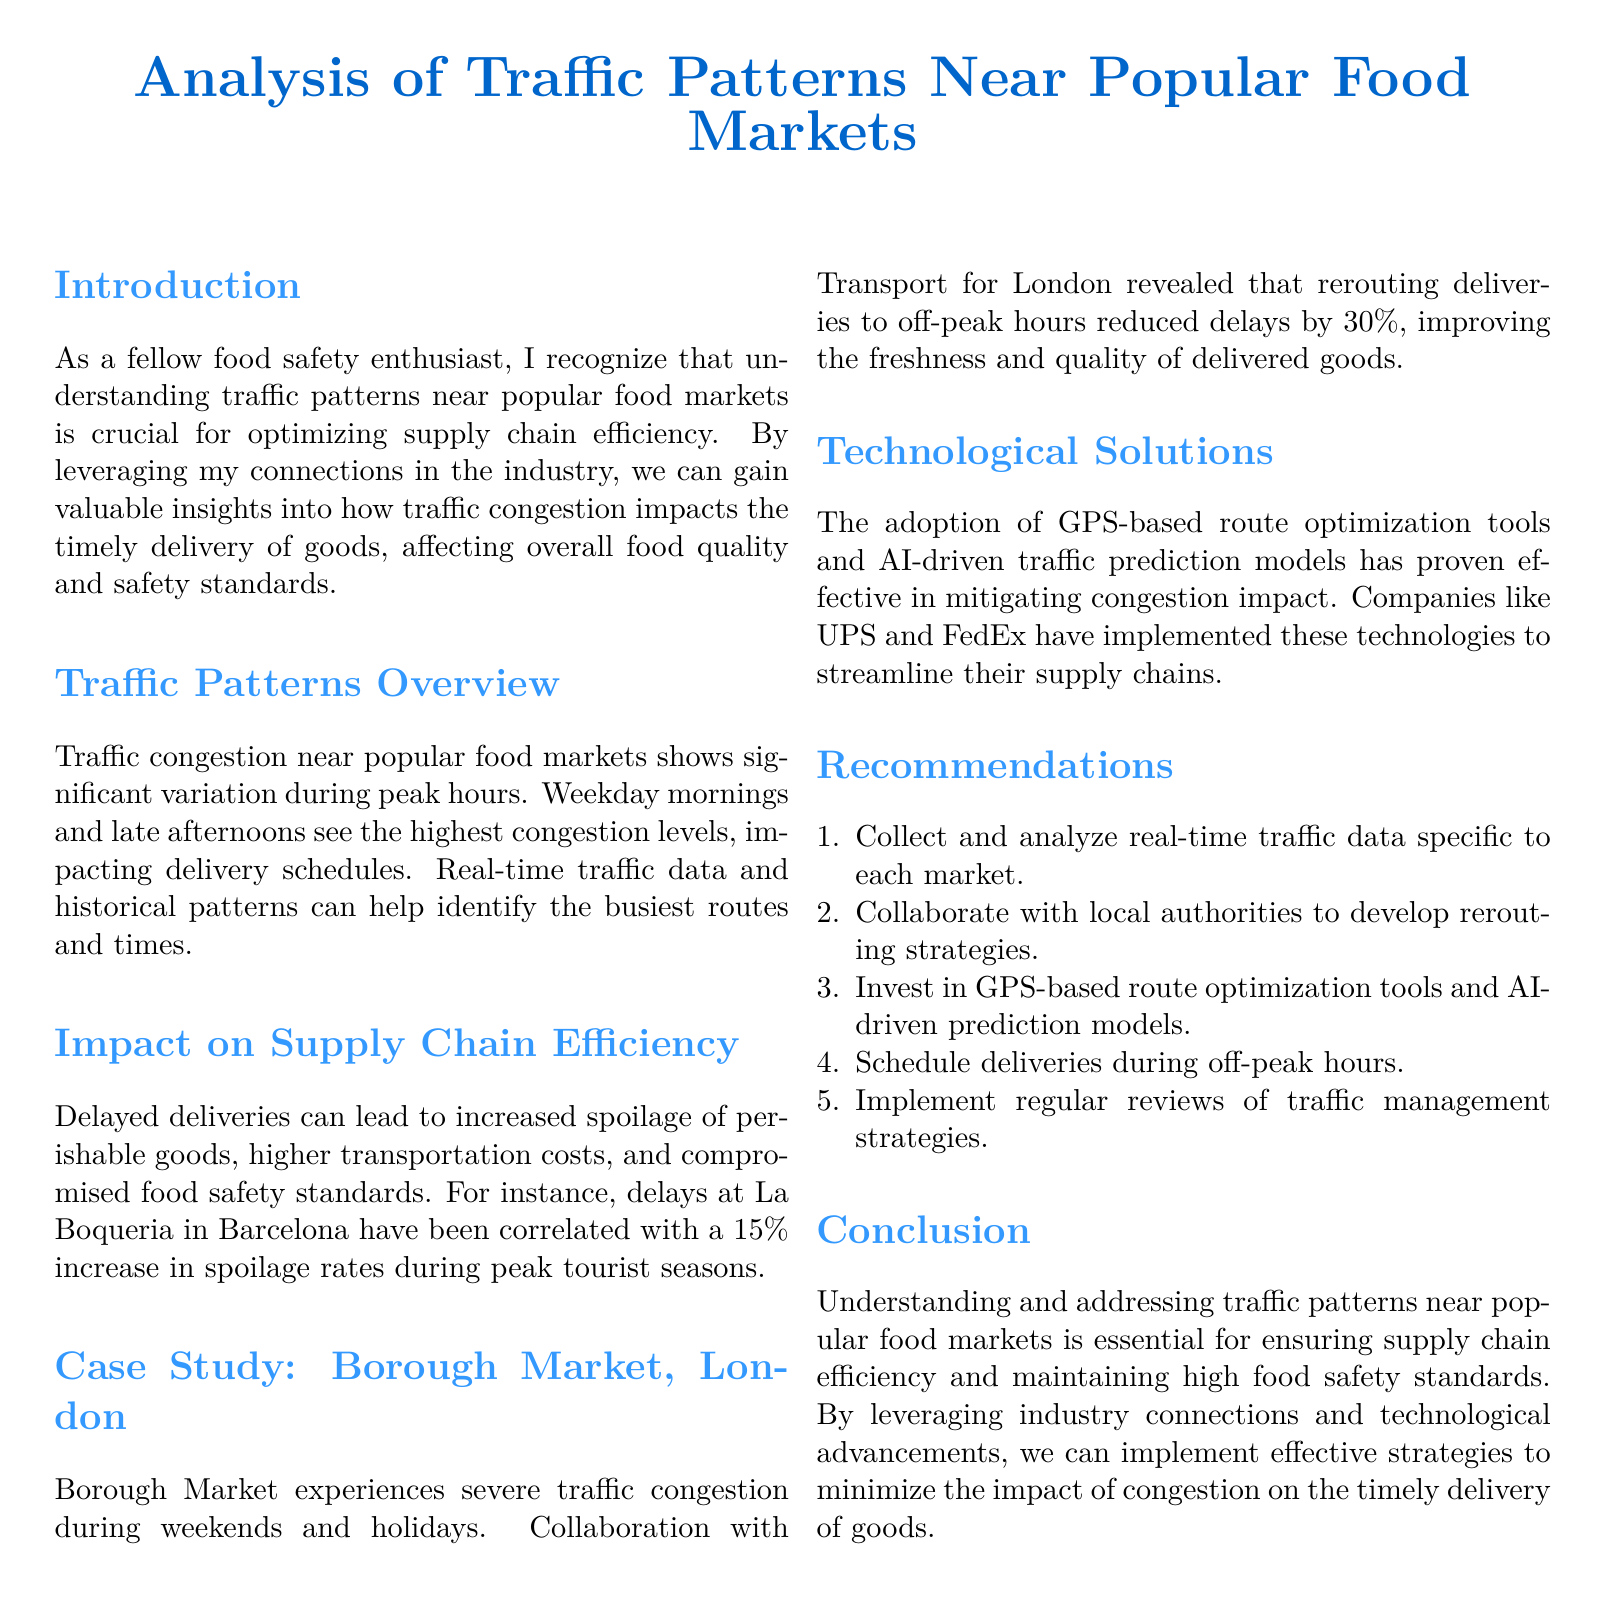What are the peak congestion times? The document states that weekday mornings and late afternoons see the highest congestion levels.
Answer: Weekday mornings and late afternoons What is the spoilage rate increase at La Boqueria? The text mentions a 15% increase in spoilage rates during peak tourist seasons at La Boqueria.
Answer: 15% What was the reduction in delays at Borough Market? The collaboration with Transport for London revealed a 30% reduction in delays after rerouting deliveries to off-peak hours.
Answer: 30% Which companies have implemented GPS-based route optimization tools? The document refers to UPS and FedEx as companies that have adopted these technologies.
Answer: UPS and FedEx What is one recommendation for improving supply chain efficiency? The document lists several recommendations, one of which is to collect and analyze real-time traffic data specific to each market.
Answer: Collect and analyze real-time traffic data What kind of data can help identify busy routes? The text mentions that real-time traffic data and historical patterns can identify the busiest routes and times.
Answer: Real-time traffic data and historical patterns What type of study is mentioned in the document? The report includes a case study focusing on Borough Market in London.
Answer: Case Study How does congestion affect food safety? The document explains that delayed deliveries can compromise food safety standards.
Answer: Compromise food safety standards 